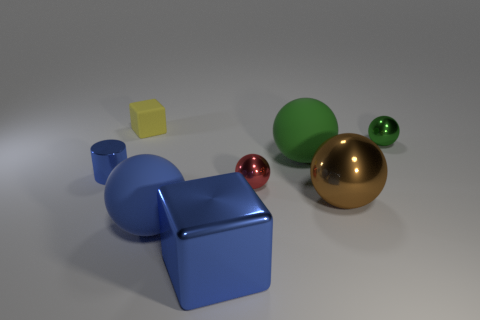Subtract all small red metal spheres. How many spheres are left? 4 Subtract all blue balls. How many balls are left? 4 Subtract all cyan balls. Subtract all yellow cylinders. How many balls are left? 5 Add 1 tiny red shiny things. How many objects exist? 9 Subtract all spheres. How many objects are left? 3 Add 7 big green objects. How many big green objects are left? 8 Add 5 green matte balls. How many green matte balls exist? 6 Subtract 1 red spheres. How many objects are left? 7 Subtract all large cyan shiny blocks. Subtract all blue shiny things. How many objects are left? 6 